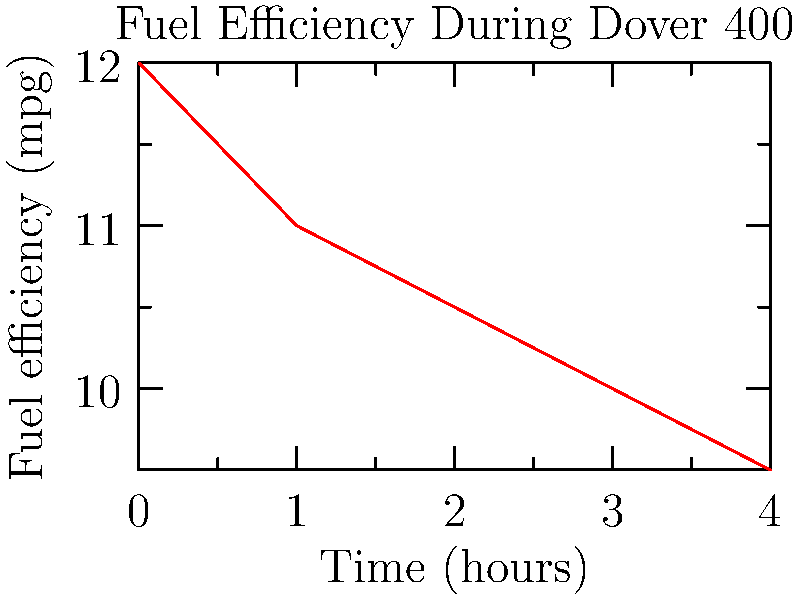During the Dover 400 race at Dover International Speedway, a driver's fuel efficiency changed over time as shown in the graph. If the race lasted 4 hours and the track is 1 mile long, how many gallons of fuel did the driver consume? To calculate the total fuel consumed, we need to:

1. Calculate the total distance traveled:
   $\text{Distance} = 400 \text{ miles}$ (given in the race name)

2. Calculate the average fuel efficiency:
   a. Efficiency values at each hour: 12, 11, 10.5, 10, 9.5 mpg
   b. Average efficiency: $\frac{12 + 11 + 10.5 + 10 + 9.5}{5} = 10.6 \text{ mpg}$

3. Calculate fuel consumed:
   $\text{Fuel consumed} = \frac{\text{Distance}}{\text{Average efficiency}}$
   $\text{Fuel consumed} = \frac{400 \text{ miles}}{10.6 \text{ mpg}} = 37.74 \text{ gallons}$

Therefore, the driver consumed approximately 37.74 gallons of fuel during the race.
Answer: 37.74 gallons 